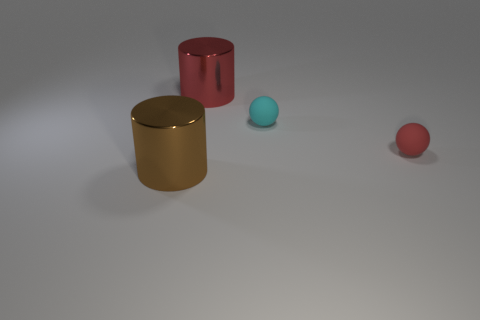Add 4 large cyan shiny cylinders. How many objects exist? 8 Subtract 0 green cubes. How many objects are left? 4 Subtract all tiny metal spheres. Subtract all brown metallic cylinders. How many objects are left? 3 Add 3 brown shiny cylinders. How many brown shiny cylinders are left? 4 Add 3 blue metal balls. How many blue metal balls exist? 3 